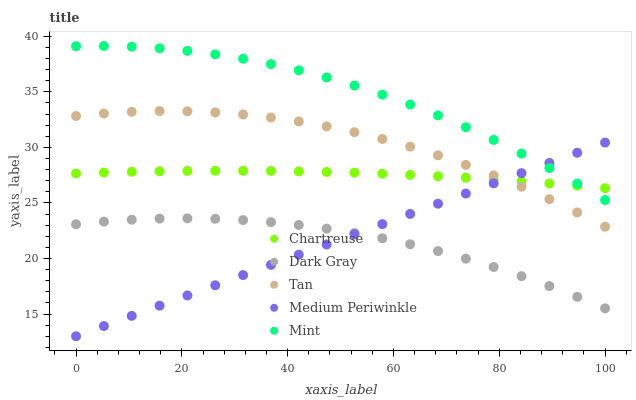Does Dark Gray have the minimum area under the curve?
Answer yes or no. Yes. Does Mint have the maximum area under the curve?
Answer yes or no. Yes. Does Chartreuse have the minimum area under the curve?
Answer yes or no. No. Does Chartreuse have the maximum area under the curve?
Answer yes or no. No. Is Medium Periwinkle the smoothest?
Answer yes or no. Yes. Is Tan the roughest?
Answer yes or no. Yes. Is Mint the smoothest?
Answer yes or no. No. Is Mint the roughest?
Answer yes or no. No. Does Medium Periwinkle have the lowest value?
Answer yes or no. Yes. Does Mint have the lowest value?
Answer yes or no. No. Does Mint have the highest value?
Answer yes or no. Yes. Does Chartreuse have the highest value?
Answer yes or no. No. Is Tan less than Mint?
Answer yes or no. Yes. Is Mint greater than Tan?
Answer yes or no. Yes. Does Chartreuse intersect Tan?
Answer yes or no. Yes. Is Chartreuse less than Tan?
Answer yes or no. No. Is Chartreuse greater than Tan?
Answer yes or no. No. Does Tan intersect Mint?
Answer yes or no. No. 